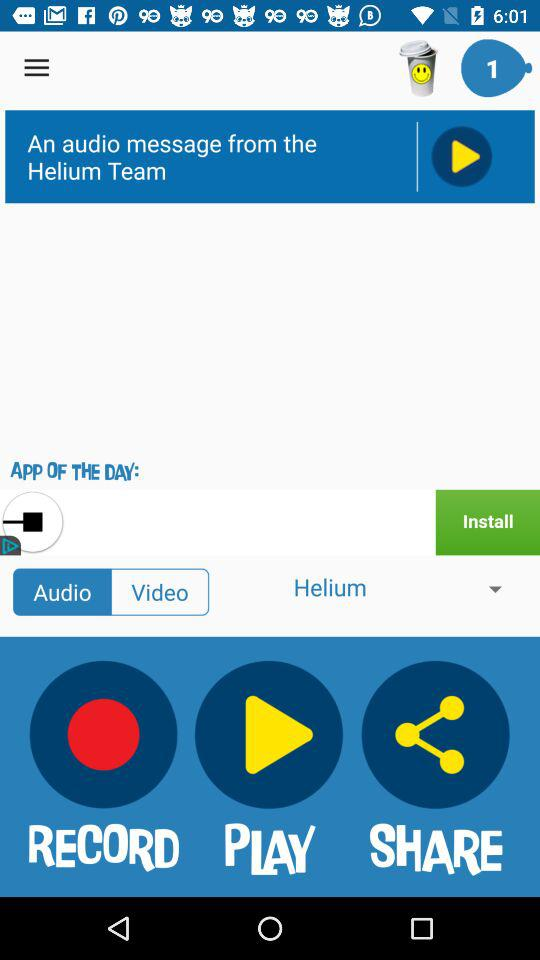Is the message audio or video? The message is audio. 